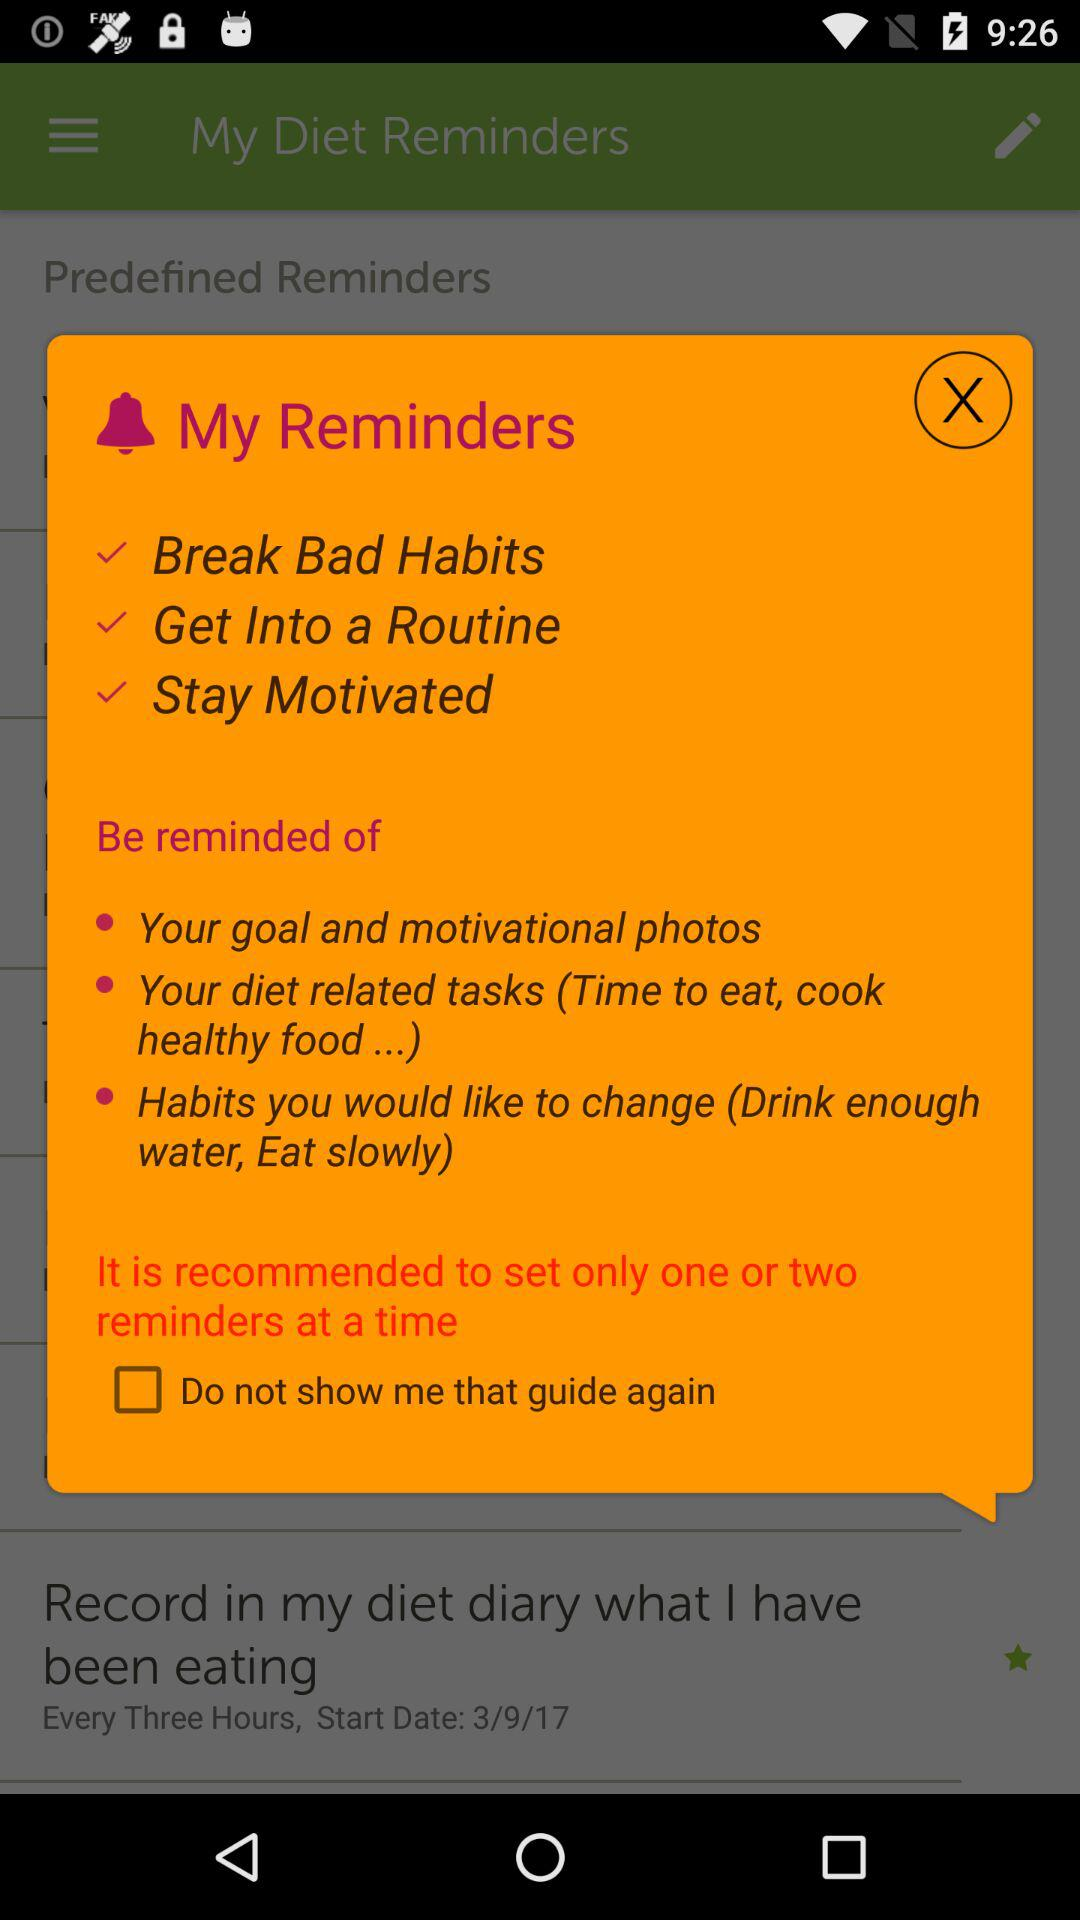What is the status of "Do not show me that guide again"? The status is "off". 